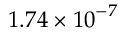<formula> <loc_0><loc_0><loc_500><loc_500>1 . 7 4 \times { { 1 0 } ^ { - 7 } }</formula> 